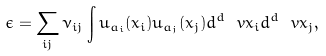<formula> <loc_0><loc_0><loc_500><loc_500>\epsilon = \sum _ { i j } \nu _ { i j } \int u _ { a _ { i } } ( x _ { i } ) u _ { a _ { j } } ( x _ { j } ) d ^ { d } \ v x _ { i } d ^ { d } \ v x _ { j } ,</formula> 